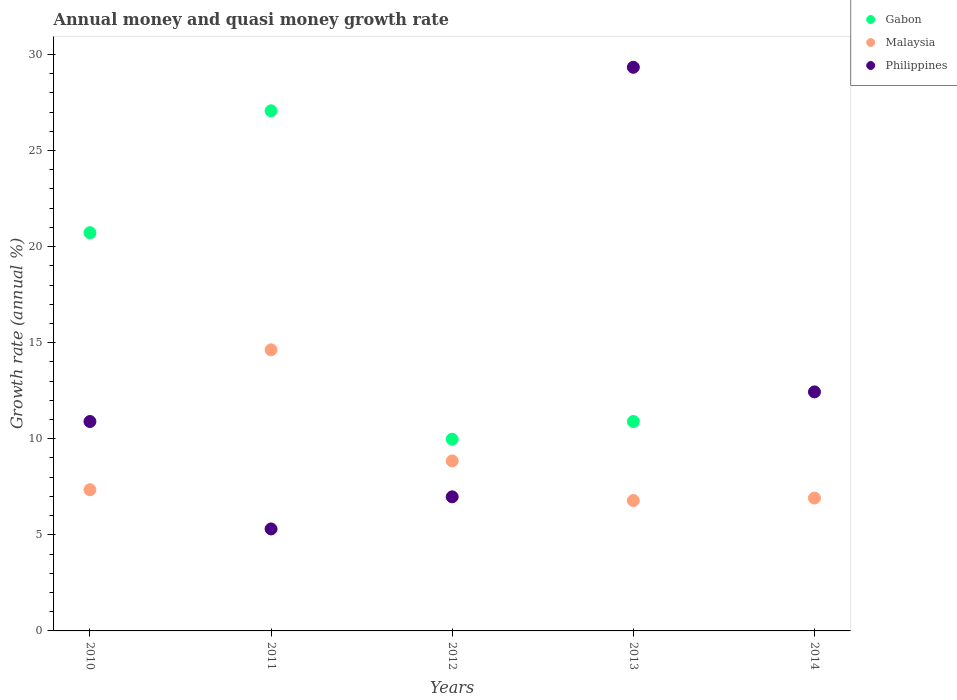How many different coloured dotlines are there?
Offer a terse response. 3. What is the growth rate in Malaysia in 2013?
Make the answer very short. 6.78. Across all years, what is the maximum growth rate in Gabon?
Offer a very short reply. 27.07. Across all years, what is the minimum growth rate in Malaysia?
Provide a succinct answer. 6.78. What is the total growth rate in Malaysia in the graph?
Make the answer very short. 44.52. What is the difference between the growth rate in Philippines in 2010 and that in 2014?
Ensure brevity in your answer.  -1.54. What is the difference between the growth rate in Philippines in 2014 and the growth rate in Malaysia in 2010?
Make the answer very short. 5.09. What is the average growth rate in Philippines per year?
Offer a terse response. 12.99. In the year 2010, what is the difference between the growth rate in Malaysia and growth rate in Philippines?
Make the answer very short. -3.55. What is the ratio of the growth rate in Gabon in 2011 to that in 2013?
Offer a very short reply. 2.48. What is the difference between the highest and the second highest growth rate in Philippines?
Make the answer very short. 16.89. What is the difference between the highest and the lowest growth rate in Gabon?
Keep it short and to the point. 27.07. Is it the case that in every year, the sum of the growth rate in Gabon and growth rate in Malaysia  is greater than the growth rate in Philippines?
Give a very brief answer. No. Is the growth rate in Malaysia strictly greater than the growth rate in Gabon over the years?
Make the answer very short. No. Is the growth rate in Malaysia strictly less than the growth rate in Gabon over the years?
Ensure brevity in your answer.  No. How many years are there in the graph?
Offer a very short reply. 5. Does the graph contain any zero values?
Keep it short and to the point. Yes. What is the title of the graph?
Your answer should be compact. Annual money and quasi money growth rate. Does "Thailand" appear as one of the legend labels in the graph?
Give a very brief answer. No. What is the label or title of the Y-axis?
Ensure brevity in your answer.  Growth rate (annual %). What is the Growth rate (annual %) in Gabon in 2010?
Ensure brevity in your answer.  20.72. What is the Growth rate (annual %) of Malaysia in 2010?
Give a very brief answer. 7.35. What is the Growth rate (annual %) of Philippines in 2010?
Keep it short and to the point. 10.9. What is the Growth rate (annual %) in Gabon in 2011?
Keep it short and to the point. 27.07. What is the Growth rate (annual %) in Malaysia in 2011?
Provide a short and direct response. 14.63. What is the Growth rate (annual %) of Philippines in 2011?
Make the answer very short. 5.31. What is the Growth rate (annual %) in Gabon in 2012?
Provide a succinct answer. 9.97. What is the Growth rate (annual %) of Malaysia in 2012?
Give a very brief answer. 8.85. What is the Growth rate (annual %) of Philippines in 2012?
Provide a succinct answer. 6.98. What is the Growth rate (annual %) of Gabon in 2013?
Your answer should be compact. 10.9. What is the Growth rate (annual %) in Malaysia in 2013?
Your response must be concise. 6.78. What is the Growth rate (annual %) of Philippines in 2013?
Give a very brief answer. 29.33. What is the Growth rate (annual %) in Malaysia in 2014?
Offer a terse response. 6.91. What is the Growth rate (annual %) of Philippines in 2014?
Provide a succinct answer. 12.44. Across all years, what is the maximum Growth rate (annual %) of Gabon?
Your answer should be very brief. 27.07. Across all years, what is the maximum Growth rate (annual %) in Malaysia?
Provide a succinct answer. 14.63. Across all years, what is the maximum Growth rate (annual %) of Philippines?
Give a very brief answer. 29.33. Across all years, what is the minimum Growth rate (annual %) in Gabon?
Keep it short and to the point. 0. Across all years, what is the minimum Growth rate (annual %) of Malaysia?
Ensure brevity in your answer.  6.78. Across all years, what is the minimum Growth rate (annual %) of Philippines?
Make the answer very short. 5.31. What is the total Growth rate (annual %) in Gabon in the graph?
Your response must be concise. 68.66. What is the total Growth rate (annual %) of Malaysia in the graph?
Ensure brevity in your answer.  44.52. What is the total Growth rate (annual %) of Philippines in the graph?
Give a very brief answer. 64.95. What is the difference between the Growth rate (annual %) in Gabon in 2010 and that in 2011?
Offer a very short reply. -6.34. What is the difference between the Growth rate (annual %) of Malaysia in 2010 and that in 2011?
Your answer should be compact. -7.28. What is the difference between the Growth rate (annual %) in Philippines in 2010 and that in 2011?
Keep it short and to the point. 5.59. What is the difference between the Growth rate (annual %) in Gabon in 2010 and that in 2012?
Ensure brevity in your answer.  10.75. What is the difference between the Growth rate (annual %) of Malaysia in 2010 and that in 2012?
Your response must be concise. -1.5. What is the difference between the Growth rate (annual %) of Philippines in 2010 and that in 2012?
Your answer should be compact. 3.92. What is the difference between the Growth rate (annual %) of Gabon in 2010 and that in 2013?
Your answer should be compact. 9.83. What is the difference between the Growth rate (annual %) of Malaysia in 2010 and that in 2013?
Ensure brevity in your answer.  0.56. What is the difference between the Growth rate (annual %) of Philippines in 2010 and that in 2013?
Make the answer very short. -18.43. What is the difference between the Growth rate (annual %) in Malaysia in 2010 and that in 2014?
Provide a succinct answer. 0.43. What is the difference between the Growth rate (annual %) of Philippines in 2010 and that in 2014?
Provide a succinct answer. -1.54. What is the difference between the Growth rate (annual %) of Gabon in 2011 and that in 2012?
Make the answer very short. 17.09. What is the difference between the Growth rate (annual %) in Malaysia in 2011 and that in 2012?
Offer a very short reply. 5.78. What is the difference between the Growth rate (annual %) in Philippines in 2011 and that in 2012?
Make the answer very short. -1.67. What is the difference between the Growth rate (annual %) in Gabon in 2011 and that in 2013?
Your answer should be compact. 16.17. What is the difference between the Growth rate (annual %) in Malaysia in 2011 and that in 2013?
Your response must be concise. 7.84. What is the difference between the Growth rate (annual %) in Philippines in 2011 and that in 2013?
Your answer should be very brief. -24.02. What is the difference between the Growth rate (annual %) in Malaysia in 2011 and that in 2014?
Provide a succinct answer. 7.71. What is the difference between the Growth rate (annual %) in Philippines in 2011 and that in 2014?
Keep it short and to the point. -7.13. What is the difference between the Growth rate (annual %) in Gabon in 2012 and that in 2013?
Offer a terse response. -0.92. What is the difference between the Growth rate (annual %) in Malaysia in 2012 and that in 2013?
Your answer should be compact. 2.06. What is the difference between the Growth rate (annual %) of Philippines in 2012 and that in 2013?
Ensure brevity in your answer.  -22.35. What is the difference between the Growth rate (annual %) of Malaysia in 2012 and that in 2014?
Your answer should be very brief. 1.93. What is the difference between the Growth rate (annual %) in Philippines in 2012 and that in 2014?
Ensure brevity in your answer.  -5.46. What is the difference between the Growth rate (annual %) in Malaysia in 2013 and that in 2014?
Make the answer very short. -0.13. What is the difference between the Growth rate (annual %) of Philippines in 2013 and that in 2014?
Keep it short and to the point. 16.89. What is the difference between the Growth rate (annual %) of Gabon in 2010 and the Growth rate (annual %) of Malaysia in 2011?
Offer a very short reply. 6.09. What is the difference between the Growth rate (annual %) of Gabon in 2010 and the Growth rate (annual %) of Philippines in 2011?
Your answer should be very brief. 15.42. What is the difference between the Growth rate (annual %) in Malaysia in 2010 and the Growth rate (annual %) in Philippines in 2011?
Ensure brevity in your answer.  2.04. What is the difference between the Growth rate (annual %) in Gabon in 2010 and the Growth rate (annual %) in Malaysia in 2012?
Give a very brief answer. 11.88. What is the difference between the Growth rate (annual %) in Gabon in 2010 and the Growth rate (annual %) in Philippines in 2012?
Your response must be concise. 13.74. What is the difference between the Growth rate (annual %) of Malaysia in 2010 and the Growth rate (annual %) of Philippines in 2012?
Your response must be concise. 0.37. What is the difference between the Growth rate (annual %) in Gabon in 2010 and the Growth rate (annual %) in Malaysia in 2013?
Provide a short and direct response. 13.94. What is the difference between the Growth rate (annual %) of Gabon in 2010 and the Growth rate (annual %) of Philippines in 2013?
Your answer should be compact. -8.61. What is the difference between the Growth rate (annual %) of Malaysia in 2010 and the Growth rate (annual %) of Philippines in 2013?
Offer a terse response. -21.98. What is the difference between the Growth rate (annual %) of Gabon in 2010 and the Growth rate (annual %) of Malaysia in 2014?
Provide a succinct answer. 13.81. What is the difference between the Growth rate (annual %) in Gabon in 2010 and the Growth rate (annual %) in Philippines in 2014?
Your answer should be very brief. 8.28. What is the difference between the Growth rate (annual %) in Malaysia in 2010 and the Growth rate (annual %) in Philippines in 2014?
Your response must be concise. -5.09. What is the difference between the Growth rate (annual %) in Gabon in 2011 and the Growth rate (annual %) in Malaysia in 2012?
Provide a short and direct response. 18.22. What is the difference between the Growth rate (annual %) in Gabon in 2011 and the Growth rate (annual %) in Philippines in 2012?
Offer a terse response. 20.09. What is the difference between the Growth rate (annual %) of Malaysia in 2011 and the Growth rate (annual %) of Philippines in 2012?
Ensure brevity in your answer.  7.65. What is the difference between the Growth rate (annual %) in Gabon in 2011 and the Growth rate (annual %) in Malaysia in 2013?
Your response must be concise. 20.28. What is the difference between the Growth rate (annual %) in Gabon in 2011 and the Growth rate (annual %) in Philippines in 2013?
Keep it short and to the point. -2.26. What is the difference between the Growth rate (annual %) in Malaysia in 2011 and the Growth rate (annual %) in Philippines in 2013?
Keep it short and to the point. -14.7. What is the difference between the Growth rate (annual %) in Gabon in 2011 and the Growth rate (annual %) in Malaysia in 2014?
Give a very brief answer. 20.15. What is the difference between the Growth rate (annual %) of Gabon in 2011 and the Growth rate (annual %) of Philippines in 2014?
Your answer should be very brief. 14.63. What is the difference between the Growth rate (annual %) in Malaysia in 2011 and the Growth rate (annual %) in Philippines in 2014?
Offer a terse response. 2.19. What is the difference between the Growth rate (annual %) of Gabon in 2012 and the Growth rate (annual %) of Malaysia in 2013?
Give a very brief answer. 3.19. What is the difference between the Growth rate (annual %) of Gabon in 2012 and the Growth rate (annual %) of Philippines in 2013?
Your response must be concise. -19.36. What is the difference between the Growth rate (annual %) of Malaysia in 2012 and the Growth rate (annual %) of Philippines in 2013?
Ensure brevity in your answer.  -20.48. What is the difference between the Growth rate (annual %) in Gabon in 2012 and the Growth rate (annual %) in Malaysia in 2014?
Ensure brevity in your answer.  3.06. What is the difference between the Growth rate (annual %) in Gabon in 2012 and the Growth rate (annual %) in Philippines in 2014?
Offer a very short reply. -2.46. What is the difference between the Growth rate (annual %) of Malaysia in 2012 and the Growth rate (annual %) of Philippines in 2014?
Offer a very short reply. -3.59. What is the difference between the Growth rate (annual %) of Gabon in 2013 and the Growth rate (annual %) of Malaysia in 2014?
Offer a very short reply. 3.98. What is the difference between the Growth rate (annual %) of Gabon in 2013 and the Growth rate (annual %) of Philippines in 2014?
Provide a succinct answer. -1.54. What is the difference between the Growth rate (annual %) in Malaysia in 2013 and the Growth rate (annual %) in Philippines in 2014?
Ensure brevity in your answer.  -5.65. What is the average Growth rate (annual %) of Gabon per year?
Make the answer very short. 13.73. What is the average Growth rate (annual %) in Malaysia per year?
Offer a terse response. 8.9. What is the average Growth rate (annual %) of Philippines per year?
Your response must be concise. 12.99. In the year 2010, what is the difference between the Growth rate (annual %) of Gabon and Growth rate (annual %) of Malaysia?
Give a very brief answer. 13.37. In the year 2010, what is the difference between the Growth rate (annual %) in Gabon and Growth rate (annual %) in Philippines?
Offer a terse response. 9.82. In the year 2010, what is the difference between the Growth rate (annual %) of Malaysia and Growth rate (annual %) of Philippines?
Offer a very short reply. -3.55. In the year 2011, what is the difference between the Growth rate (annual %) of Gabon and Growth rate (annual %) of Malaysia?
Offer a terse response. 12.44. In the year 2011, what is the difference between the Growth rate (annual %) of Gabon and Growth rate (annual %) of Philippines?
Offer a terse response. 21.76. In the year 2011, what is the difference between the Growth rate (annual %) of Malaysia and Growth rate (annual %) of Philippines?
Your answer should be very brief. 9.32. In the year 2012, what is the difference between the Growth rate (annual %) in Gabon and Growth rate (annual %) in Malaysia?
Give a very brief answer. 1.13. In the year 2012, what is the difference between the Growth rate (annual %) of Gabon and Growth rate (annual %) of Philippines?
Provide a succinct answer. 3. In the year 2012, what is the difference between the Growth rate (annual %) of Malaysia and Growth rate (annual %) of Philippines?
Provide a succinct answer. 1.87. In the year 2013, what is the difference between the Growth rate (annual %) of Gabon and Growth rate (annual %) of Malaysia?
Give a very brief answer. 4.11. In the year 2013, what is the difference between the Growth rate (annual %) in Gabon and Growth rate (annual %) in Philippines?
Your answer should be very brief. -18.43. In the year 2013, what is the difference between the Growth rate (annual %) of Malaysia and Growth rate (annual %) of Philippines?
Provide a short and direct response. -22.55. In the year 2014, what is the difference between the Growth rate (annual %) of Malaysia and Growth rate (annual %) of Philippines?
Offer a very short reply. -5.52. What is the ratio of the Growth rate (annual %) in Gabon in 2010 to that in 2011?
Make the answer very short. 0.77. What is the ratio of the Growth rate (annual %) in Malaysia in 2010 to that in 2011?
Ensure brevity in your answer.  0.5. What is the ratio of the Growth rate (annual %) of Philippines in 2010 to that in 2011?
Provide a succinct answer. 2.05. What is the ratio of the Growth rate (annual %) of Gabon in 2010 to that in 2012?
Offer a terse response. 2.08. What is the ratio of the Growth rate (annual %) in Malaysia in 2010 to that in 2012?
Keep it short and to the point. 0.83. What is the ratio of the Growth rate (annual %) of Philippines in 2010 to that in 2012?
Offer a very short reply. 1.56. What is the ratio of the Growth rate (annual %) in Gabon in 2010 to that in 2013?
Offer a terse response. 1.9. What is the ratio of the Growth rate (annual %) in Malaysia in 2010 to that in 2013?
Your answer should be compact. 1.08. What is the ratio of the Growth rate (annual %) of Philippines in 2010 to that in 2013?
Provide a short and direct response. 0.37. What is the ratio of the Growth rate (annual %) of Malaysia in 2010 to that in 2014?
Ensure brevity in your answer.  1.06. What is the ratio of the Growth rate (annual %) in Philippines in 2010 to that in 2014?
Provide a succinct answer. 0.88. What is the ratio of the Growth rate (annual %) in Gabon in 2011 to that in 2012?
Provide a short and direct response. 2.71. What is the ratio of the Growth rate (annual %) in Malaysia in 2011 to that in 2012?
Provide a succinct answer. 1.65. What is the ratio of the Growth rate (annual %) of Philippines in 2011 to that in 2012?
Provide a succinct answer. 0.76. What is the ratio of the Growth rate (annual %) of Gabon in 2011 to that in 2013?
Make the answer very short. 2.48. What is the ratio of the Growth rate (annual %) of Malaysia in 2011 to that in 2013?
Ensure brevity in your answer.  2.16. What is the ratio of the Growth rate (annual %) of Philippines in 2011 to that in 2013?
Make the answer very short. 0.18. What is the ratio of the Growth rate (annual %) in Malaysia in 2011 to that in 2014?
Your answer should be very brief. 2.12. What is the ratio of the Growth rate (annual %) of Philippines in 2011 to that in 2014?
Make the answer very short. 0.43. What is the ratio of the Growth rate (annual %) in Gabon in 2012 to that in 2013?
Provide a short and direct response. 0.92. What is the ratio of the Growth rate (annual %) in Malaysia in 2012 to that in 2013?
Offer a terse response. 1.3. What is the ratio of the Growth rate (annual %) in Philippines in 2012 to that in 2013?
Your response must be concise. 0.24. What is the ratio of the Growth rate (annual %) in Malaysia in 2012 to that in 2014?
Make the answer very short. 1.28. What is the ratio of the Growth rate (annual %) in Philippines in 2012 to that in 2014?
Make the answer very short. 0.56. What is the ratio of the Growth rate (annual %) in Malaysia in 2013 to that in 2014?
Offer a terse response. 0.98. What is the ratio of the Growth rate (annual %) of Philippines in 2013 to that in 2014?
Offer a terse response. 2.36. What is the difference between the highest and the second highest Growth rate (annual %) in Gabon?
Your answer should be very brief. 6.34. What is the difference between the highest and the second highest Growth rate (annual %) of Malaysia?
Keep it short and to the point. 5.78. What is the difference between the highest and the second highest Growth rate (annual %) in Philippines?
Ensure brevity in your answer.  16.89. What is the difference between the highest and the lowest Growth rate (annual %) of Gabon?
Your response must be concise. 27.07. What is the difference between the highest and the lowest Growth rate (annual %) in Malaysia?
Provide a short and direct response. 7.84. What is the difference between the highest and the lowest Growth rate (annual %) in Philippines?
Offer a very short reply. 24.02. 